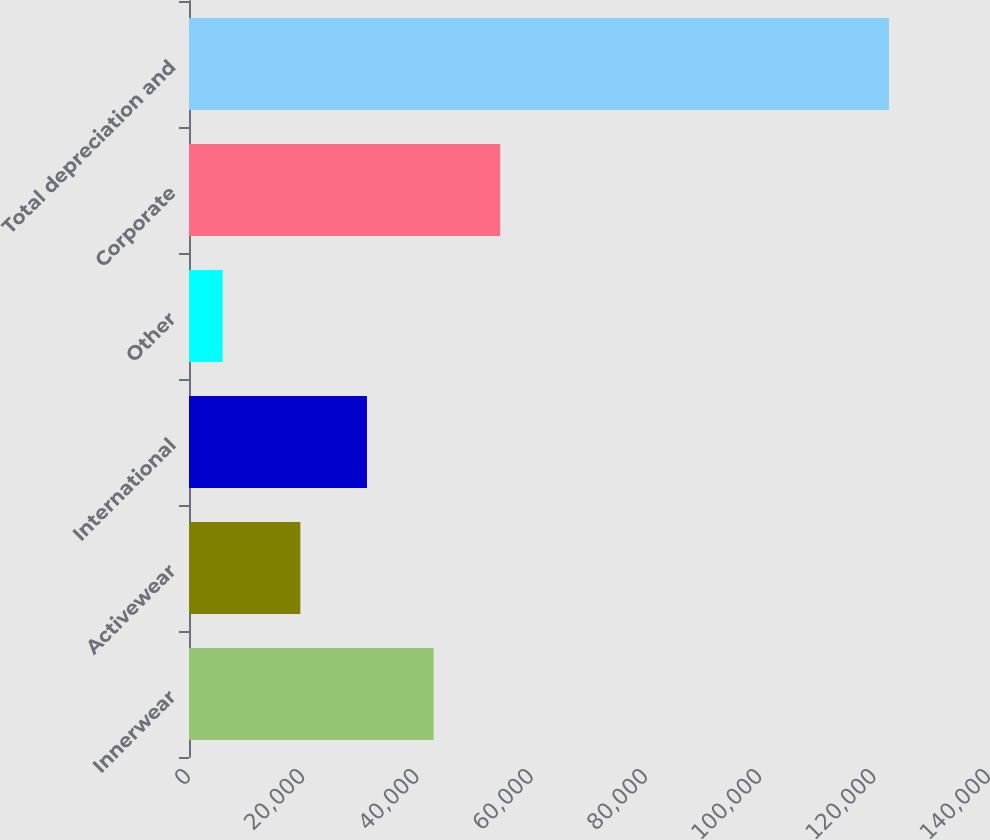Convert chart. <chart><loc_0><loc_0><loc_500><loc_500><bar_chart><fcel>Innerwear<fcel>Activewear<fcel>International<fcel>Other<fcel>Corporate<fcel>Total depreciation and<nl><fcel>42804.2<fcel>19485<fcel>31144.6<fcel>5891<fcel>54463.8<fcel>122487<nl></chart> 